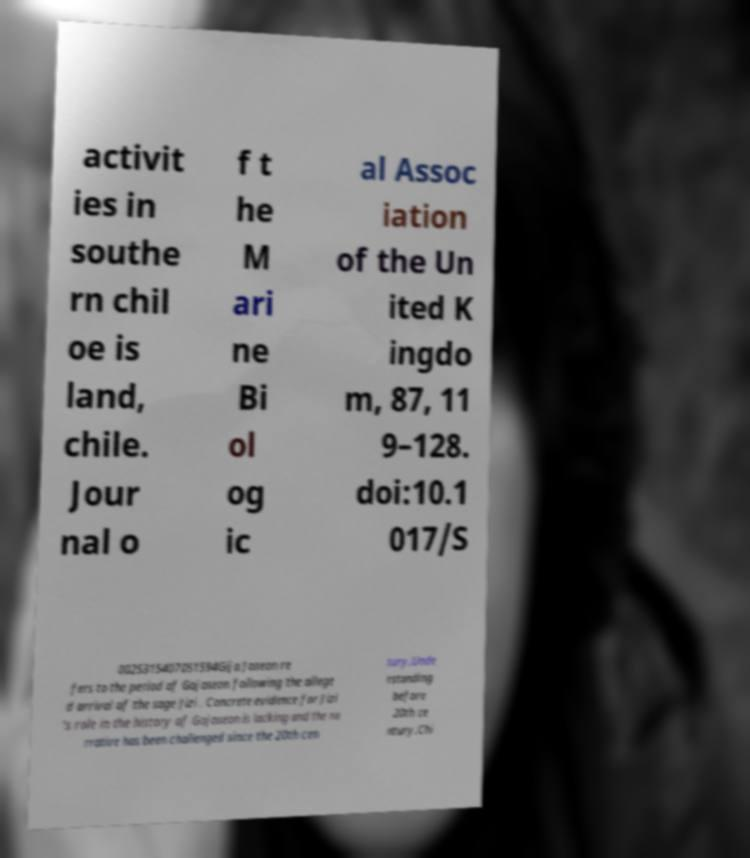Please read and relay the text visible in this image. What does it say? activit ies in southe rn chil oe is land, chile. Jour nal o f t he M ari ne Bi ol og ic al Assoc iation of the Un ited K ingdo m, 87, 11 9–128. doi:10.1 017/S 0025315407051594Gija Joseon re fers to the period of Gojoseon following the allege d arrival of the sage Jizi . Concrete evidence for Jizi 's role in the history of Gojoseon is lacking and the na rrative has been challenged since the 20th cen tury.Unde rstanding before 20th ce ntury.Chi 